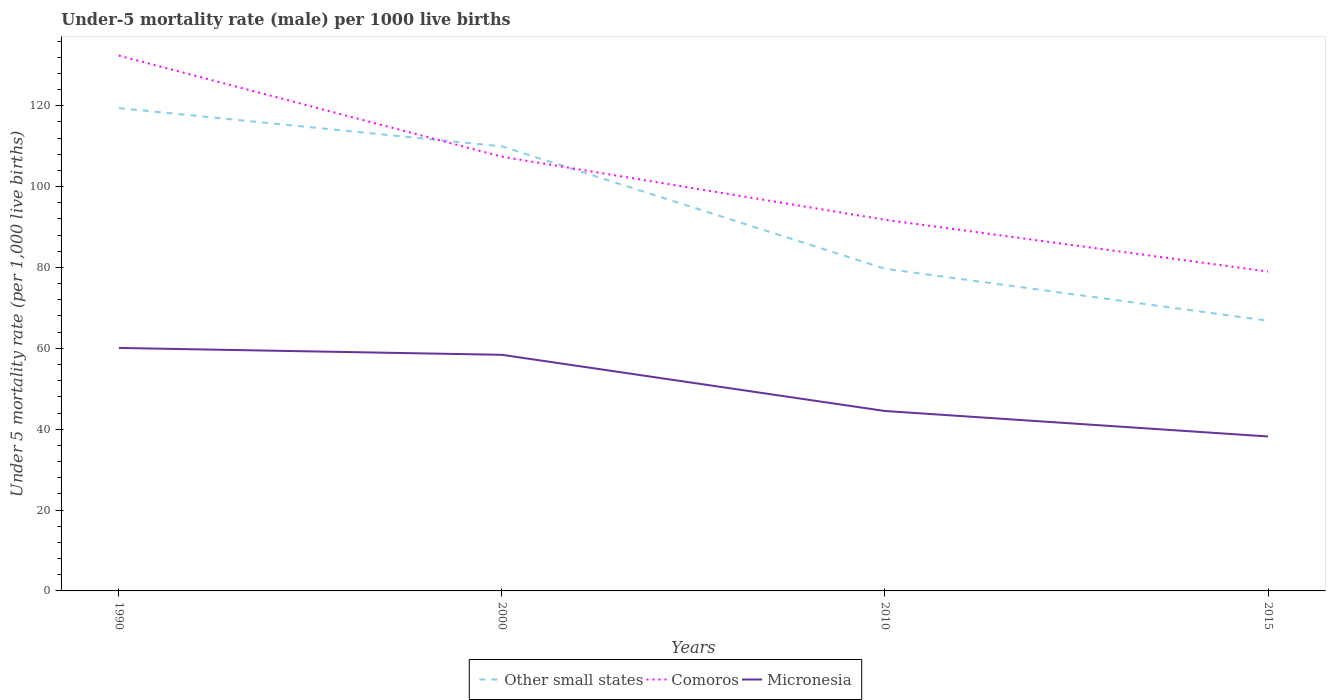How many different coloured lines are there?
Offer a very short reply. 3. Does the line corresponding to Micronesia intersect with the line corresponding to Comoros?
Your answer should be compact. No. Is the number of lines equal to the number of legend labels?
Keep it short and to the point. Yes. Across all years, what is the maximum under-five mortality rate in Micronesia?
Keep it short and to the point. 38.2. In which year was the under-five mortality rate in Other small states maximum?
Your answer should be compact. 2015. What is the total under-five mortality rate in Micronesia in the graph?
Give a very brief answer. 15.6. What is the difference between the highest and the second highest under-five mortality rate in Comoros?
Provide a short and direct response. 53.4. What is the difference between the highest and the lowest under-five mortality rate in Micronesia?
Ensure brevity in your answer.  2. Is the under-five mortality rate in Other small states strictly greater than the under-five mortality rate in Micronesia over the years?
Ensure brevity in your answer.  No. How many lines are there?
Your answer should be compact. 3. What is the difference between two consecutive major ticks on the Y-axis?
Offer a terse response. 20. Does the graph contain any zero values?
Keep it short and to the point. No. Does the graph contain grids?
Your answer should be very brief. No. Where does the legend appear in the graph?
Offer a very short reply. Bottom center. How are the legend labels stacked?
Keep it short and to the point. Horizontal. What is the title of the graph?
Provide a short and direct response. Under-5 mortality rate (male) per 1000 live births. Does "OECD members" appear as one of the legend labels in the graph?
Provide a succinct answer. No. What is the label or title of the Y-axis?
Ensure brevity in your answer.  Under 5 mortality rate (per 1,0 live births). What is the Under 5 mortality rate (per 1,000 live births) of Other small states in 1990?
Provide a succinct answer. 119.42. What is the Under 5 mortality rate (per 1,000 live births) in Comoros in 1990?
Give a very brief answer. 132.4. What is the Under 5 mortality rate (per 1,000 live births) of Micronesia in 1990?
Offer a terse response. 60.1. What is the Under 5 mortality rate (per 1,000 live births) of Other small states in 2000?
Your response must be concise. 109.95. What is the Under 5 mortality rate (per 1,000 live births) of Comoros in 2000?
Provide a short and direct response. 107.4. What is the Under 5 mortality rate (per 1,000 live births) in Micronesia in 2000?
Your response must be concise. 58.4. What is the Under 5 mortality rate (per 1,000 live births) of Other small states in 2010?
Ensure brevity in your answer.  79.69. What is the Under 5 mortality rate (per 1,000 live births) of Comoros in 2010?
Your response must be concise. 91.8. What is the Under 5 mortality rate (per 1,000 live births) of Micronesia in 2010?
Offer a very short reply. 44.5. What is the Under 5 mortality rate (per 1,000 live births) in Other small states in 2015?
Make the answer very short. 66.83. What is the Under 5 mortality rate (per 1,000 live births) of Comoros in 2015?
Give a very brief answer. 79. What is the Under 5 mortality rate (per 1,000 live births) of Micronesia in 2015?
Your response must be concise. 38.2. Across all years, what is the maximum Under 5 mortality rate (per 1,000 live births) of Other small states?
Your answer should be compact. 119.42. Across all years, what is the maximum Under 5 mortality rate (per 1,000 live births) of Comoros?
Ensure brevity in your answer.  132.4. Across all years, what is the maximum Under 5 mortality rate (per 1,000 live births) of Micronesia?
Make the answer very short. 60.1. Across all years, what is the minimum Under 5 mortality rate (per 1,000 live births) of Other small states?
Offer a very short reply. 66.83. Across all years, what is the minimum Under 5 mortality rate (per 1,000 live births) of Comoros?
Ensure brevity in your answer.  79. Across all years, what is the minimum Under 5 mortality rate (per 1,000 live births) in Micronesia?
Your response must be concise. 38.2. What is the total Under 5 mortality rate (per 1,000 live births) in Other small states in the graph?
Provide a succinct answer. 375.9. What is the total Under 5 mortality rate (per 1,000 live births) of Comoros in the graph?
Keep it short and to the point. 410.6. What is the total Under 5 mortality rate (per 1,000 live births) of Micronesia in the graph?
Make the answer very short. 201.2. What is the difference between the Under 5 mortality rate (per 1,000 live births) in Other small states in 1990 and that in 2000?
Give a very brief answer. 9.47. What is the difference between the Under 5 mortality rate (per 1,000 live births) in Comoros in 1990 and that in 2000?
Provide a short and direct response. 25. What is the difference between the Under 5 mortality rate (per 1,000 live births) of Micronesia in 1990 and that in 2000?
Offer a terse response. 1.7. What is the difference between the Under 5 mortality rate (per 1,000 live births) in Other small states in 1990 and that in 2010?
Offer a terse response. 39.73. What is the difference between the Under 5 mortality rate (per 1,000 live births) of Comoros in 1990 and that in 2010?
Offer a very short reply. 40.6. What is the difference between the Under 5 mortality rate (per 1,000 live births) in Micronesia in 1990 and that in 2010?
Make the answer very short. 15.6. What is the difference between the Under 5 mortality rate (per 1,000 live births) in Other small states in 1990 and that in 2015?
Make the answer very short. 52.59. What is the difference between the Under 5 mortality rate (per 1,000 live births) of Comoros in 1990 and that in 2015?
Keep it short and to the point. 53.4. What is the difference between the Under 5 mortality rate (per 1,000 live births) in Micronesia in 1990 and that in 2015?
Your answer should be compact. 21.9. What is the difference between the Under 5 mortality rate (per 1,000 live births) in Other small states in 2000 and that in 2010?
Your answer should be compact. 30.26. What is the difference between the Under 5 mortality rate (per 1,000 live births) in Micronesia in 2000 and that in 2010?
Make the answer very short. 13.9. What is the difference between the Under 5 mortality rate (per 1,000 live births) in Other small states in 2000 and that in 2015?
Your answer should be very brief. 43.12. What is the difference between the Under 5 mortality rate (per 1,000 live births) in Comoros in 2000 and that in 2015?
Ensure brevity in your answer.  28.4. What is the difference between the Under 5 mortality rate (per 1,000 live births) in Micronesia in 2000 and that in 2015?
Ensure brevity in your answer.  20.2. What is the difference between the Under 5 mortality rate (per 1,000 live births) of Other small states in 2010 and that in 2015?
Provide a succinct answer. 12.86. What is the difference between the Under 5 mortality rate (per 1,000 live births) in Comoros in 2010 and that in 2015?
Provide a short and direct response. 12.8. What is the difference between the Under 5 mortality rate (per 1,000 live births) in Micronesia in 2010 and that in 2015?
Make the answer very short. 6.3. What is the difference between the Under 5 mortality rate (per 1,000 live births) in Other small states in 1990 and the Under 5 mortality rate (per 1,000 live births) in Comoros in 2000?
Provide a short and direct response. 12.02. What is the difference between the Under 5 mortality rate (per 1,000 live births) in Other small states in 1990 and the Under 5 mortality rate (per 1,000 live births) in Micronesia in 2000?
Your answer should be very brief. 61.02. What is the difference between the Under 5 mortality rate (per 1,000 live births) of Comoros in 1990 and the Under 5 mortality rate (per 1,000 live births) of Micronesia in 2000?
Your answer should be compact. 74. What is the difference between the Under 5 mortality rate (per 1,000 live births) in Other small states in 1990 and the Under 5 mortality rate (per 1,000 live births) in Comoros in 2010?
Offer a terse response. 27.62. What is the difference between the Under 5 mortality rate (per 1,000 live births) of Other small states in 1990 and the Under 5 mortality rate (per 1,000 live births) of Micronesia in 2010?
Provide a short and direct response. 74.92. What is the difference between the Under 5 mortality rate (per 1,000 live births) of Comoros in 1990 and the Under 5 mortality rate (per 1,000 live births) of Micronesia in 2010?
Give a very brief answer. 87.9. What is the difference between the Under 5 mortality rate (per 1,000 live births) in Other small states in 1990 and the Under 5 mortality rate (per 1,000 live births) in Comoros in 2015?
Ensure brevity in your answer.  40.42. What is the difference between the Under 5 mortality rate (per 1,000 live births) in Other small states in 1990 and the Under 5 mortality rate (per 1,000 live births) in Micronesia in 2015?
Ensure brevity in your answer.  81.22. What is the difference between the Under 5 mortality rate (per 1,000 live births) of Comoros in 1990 and the Under 5 mortality rate (per 1,000 live births) of Micronesia in 2015?
Keep it short and to the point. 94.2. What is the difference between the Under 5 mortality rate (per 1,000 live births) in Other small states in 2000 and the Under 5 mortality rate (per 1,000 live births) in Comoros in 2010?
Ensure brevity in your answer.  18.15. What is the difference between the Under 5 mortality rate (per 1,000 live births) of Other small states in 2000 and the Under 5 mortality rate (per 1,000 live births) of Micronesia in 2010?
Give a very brief answer. 65.45. What is the difference between the Under 5 mortality rate (per 1,000 live births) in Comoros in 2000 and the Under 5 mortality rate (per 1,000 live births) in Micronesia in 2010?
Your response must be concise. 62.9. What is the difference between the Under 5 mortality rate (per 1,000 live births) in Other small states in 2000 and the Under 5 mortality rate (per 1,000 live births) in Comoros in 2015?
Your answer should be very brief. 30.95. What is the difference between the Under 5 mortality rate (per 1,000 live births) of Other small states in 2000 and the Under 5 mortality rate (per 1,000 live births) of Micronesia in 2015?
Provide a succinct answer. 71.75. What is the difference between the Under 5 mortality rate (per 1,000 live births) in Comoros in 2000 and the Under 5 mortality rate (per 1,000 live births) in Micronesia in 2015?
Your answer should be very brief. 69.2. What is the difference between the Under 5 mortality rate (per 1,000 live births) in Other small states in 2010 and the Under 5 mortality rate (per 1,000 live births) in Comoros in 2015?
Make the answer very short. 0.69. What is the difference between the Under 5 mortality rate (per 1,000 live births) in Other small states in 2010 and the Under 5 mortality rate (per 1,000 live births) in Micronesia in 2015?
Your response must be concise. 41.49. What is the difference between the Under 5 mortality rate (per 1,000 live births) of Comoros in 2010 and the Under 5 mortality rate (per 1,000 live births) of Micronesia in 2015?
Your response must be concise. 53.6. What is the average Under 5 mortality rate (per 1,000 live births) in Other small states per year?
Your answer should be compact. 93.97. What is the average Under 5 mortality rate (per 1,000 live births) of Comoros per year?
Offer a very short reply. 102.65. What is the average Under 5 mortality rate (per 1,000 live births) in Micronesia per year?
Keep it short and to the point. 50.3. In the year 1990, what is the difference between the Under 5 mortality rate (per 1,000 live births) in Other small states and Under 5 mortality rate (per 1,000 live births) in Comoros?
Your answer should be compact. -12.98. In the year 1990, what is the difference between the Under 5 mortality rate (per 1,000 live births) of Other small states and Under 5 mortality rate (per 1,000 live births) of Micronesia?
Your response must be concise. 59.32. In the year 1990, what is the difference between the Under 5 mortality rate (per 1,000 live births) of Comoros and Under 5 mortality rate (per 1,000 live births) of Micronesia?
Ensure brevity in your answer.  72.3. In the year 2000, what is the difference between the Under 5 mortality rate (per 1,000 live births) in Other small states and Under 5 mortality rate (per 1,000 live births) in Comoros?
Your answer should be very brief. 2.55. In the year 2000, what is the difference between the Under 5 mortality rate (per 1,000 live births) of Other small states and Under 5 mortality rate (per 1,000 live births) of Micronesia?
Provide a short and direct response. 51.55. In the year 2010, what is the difference between the Under 5 mortality rate (per 1,000 live births) of Other small states and Under 5 mortality rate (per 1,000 live births) of Comoros?
Your answer should be very brief. -12.11. In the year 2010, what is the difference between the Under 5 mortality rate (per 1,000 live births) in Other small states and Under 5 mortality rate (per 1,000 live births) in Micronesia?
Offer a very short reply. 35.19. In the year 2010, what is the difference between the Under 5 mortality rate (per 1,000 live births) of Comoros and Under 5 mortality rate (per 1,000 live births) of Micronesia?
Keep it short and to the point. 47.3. In the year 2015, what is the difference between the Under 5 mortality rate (per 1,000 live births) of Other small states and Under 5 mortality rate (per 1,000 live births) of Comoros?
Your answer should be very brief. -12.17. In the year 2015, what is the difference between the Under 5 mortality rate (per 1,000 live births) of Other small states and Under 5 mortality rate (per 1,000 live births) of Micronesia?
Keep it short and to the point. 28.63. In the year 2015, what is the difference between the Under 5 mortality rate (per 1,000 live births) in Comoros and Under 5 mortality rate (per 1,000 live births) in Micronesia?
Offer a very short reply. 40.8. What is the ratio of the Under 5 mortality rate (per 1,000 live births) in Other small states in 1990 to that in 2000?
Keep it short and to the point. 1.09. What is the ratio of the Under 5 mortality rate (per 1,000 live births) of Comoros in 1990 to that in 2000?
Provide a succinct answer. 1.23. What is the ratio of the Under 5 mortality rate (per 1,000 live births) in Micronesia in 1990 to that in 2000?
Ensure brevity in your answer.  1.03. What is the ratio of the Under 5 mortality rate (per 1,000 live births) in Other small states in 1990 to that in 2010?
Offer a terse response. 1.5. What is the ratio of the Under 5 mortality rate (per 1,000 live births) in Comoros in 1990 to that in 2010?
Make the answer very short. 1.44. What is the ratio of the Under 5 mortality rate (per 1,000 live births) in Micronesia in 1990 to that in 2010?
Ensure brevity in your answer.  1.35. What is the ratio of the Under 5 mortality rate (per 1,000 live births) in Other small states in 1990 to that in 2015?
Your response must be concise. 1.79. What is the ratio of the Under 5 mortality rate (per 1,000 live births) of Comoros in 1990 to that in 2015?
Keep it short and to the point. 1.68. What is the ratio of the Under 5 mortality rate (per 1,000 live births) of Micronesia in 1990 to that in 2015?
Your answer should be very brief. 1.57. What is the ratio of the Under 5 mortality rate (per 1,000 live births) in Other small states in 2000 to that in 2010?
Keep it short and to the point. 1.38. What is the ratio of the Under 5 mortality rate (per 1,000 live births) in Comoros in 2000 to that in 2010?
Offer a very short reply. 1.17. What is the ratio of the Under 5 mortality rate (per 1,000 live births) of Micronesia in 2000 to that in 2010?
Your answer should be compact. 1.31. What is the ratio of the Under 5 mortality rate (per 1,000 live births) in Other small states in 2000 to that in 2015?
Provide a succinct answer. 1.65. What is the ratio of the Under 5 mortality rate (per 1,000 live births) in Comoros in 2000 to that in 2015?
Ensure brevity in your answer.  1.36. What is the ratio of the Under 5 mortality rate (per 1,000 live births) of Micronesia in 2000 to that in 2015?
Ensure brevity in your answer.  1.53. What is the ratio of the Under 5 mortality rate (per 1,000 live births) in Other small states in 2010 to that in 2015?
Offer a very short reply. 1.19. What is the ratio of the Under 5 mortality rate (per 1,000 live births) of Comoros in 2010 to that in 2015?
Give a very brief answer. 1.16. What is the ratio of the Under 5 mortality rate (per 1,000 live births) in Micronesia in 2010 to that in 2015?
Keep it short and to the point. 1.16. What is the difference between the highest and the second highest Under 5 mortality rate (per 1,000 live births) in Other small states?
Offer a terse response. 9.47. What is the difference between the highest and the lowest Under 5 mortality rate (per 1,000 live births) in Other small states?
Your response must be concise. 52.59. What is the difference between the highest and the lowest Under 5 mortality rate (per 1,000 live births) of Comoros?
Offer a terse response. 53.4. What is the difference between the highest and the lowest Under 5 mortality rate (per 1,000 live births) in Micronesia?
Ensure brevity in your answer.  21.9. 